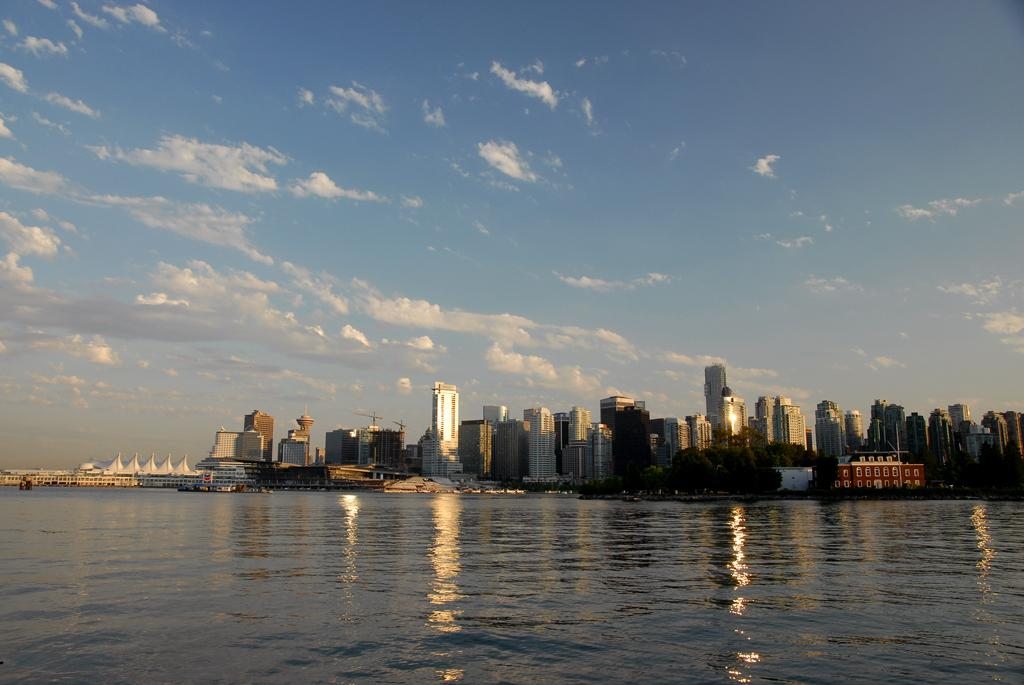What is visible at the bottom of the image? There is water visible at the bottom of the image. What can be seen in the background of the image? Buildings, cranes, trees, poles, and clouds are present in the background of the image. What type of plantation can be seen in the image? There is no plantation present in the image. What letters are visible on the locket in the image? There is no locket present in the image. 